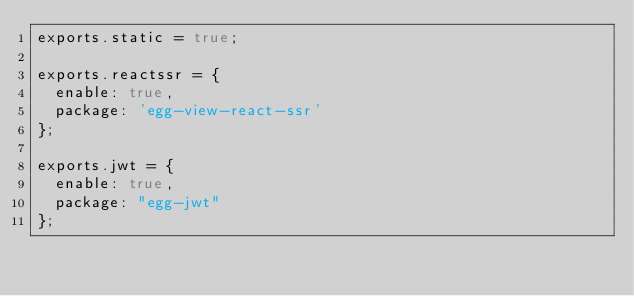<code> <loc_0><loc_0><loc_500><loc_500><_JavaScript_>exports.static = true;

exports.reactssr = {
  enable: true,
  package: 'egg-view-react-ssr'
};

exports.jwt = {
  enable: true,
  package: "egg-jwt"
};
</code> 